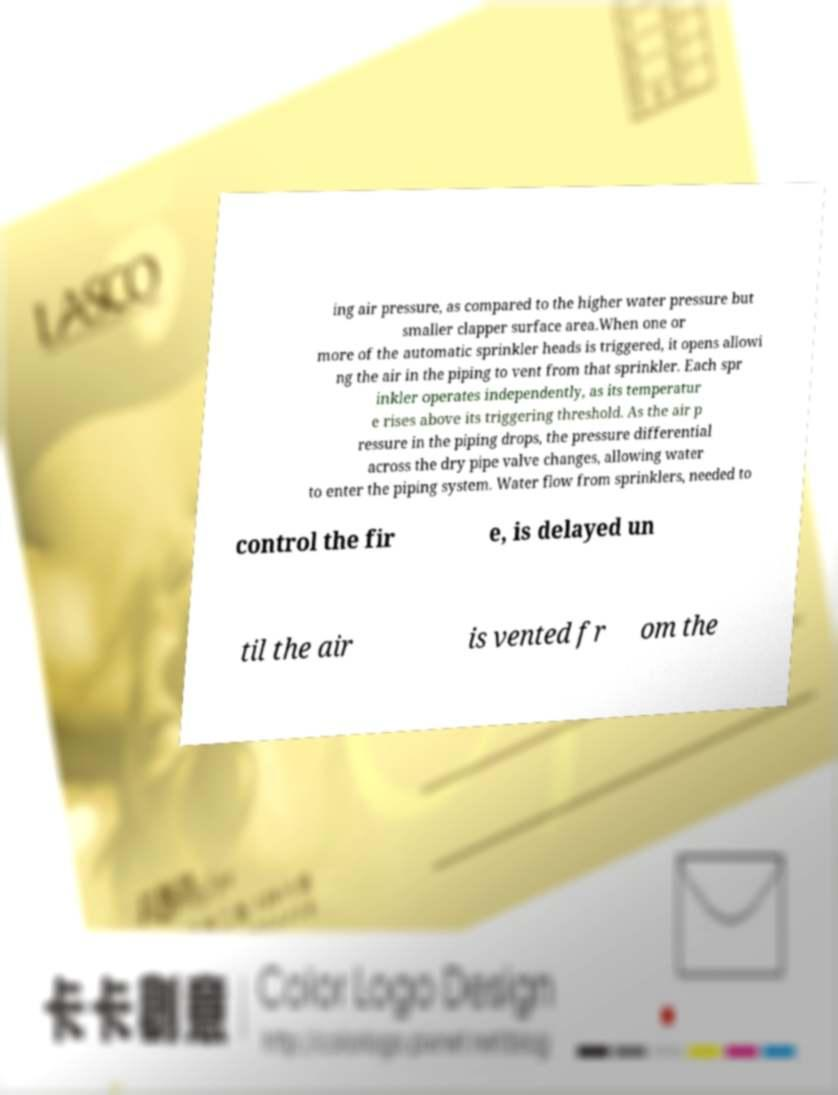I need the written content from this picture converted into text. Can you do that? ing air pressure, as compared to the higher water pressure but smaller clapper surface area.When one or more of the automatic sprinkler heads is triggered, it opens allowi ng the air in the piping to vent from that sprinkler. Each spr inkler operates independently, as its temperatur e rises above its triggering threshold. As the air p ressure in the piping drops, the pressure differential across the dry pipe valve changes, allowing water to enter the piping system. Water flow from sprinklers, needed to control the fir e, is delayed un til the air is vented fr om the 